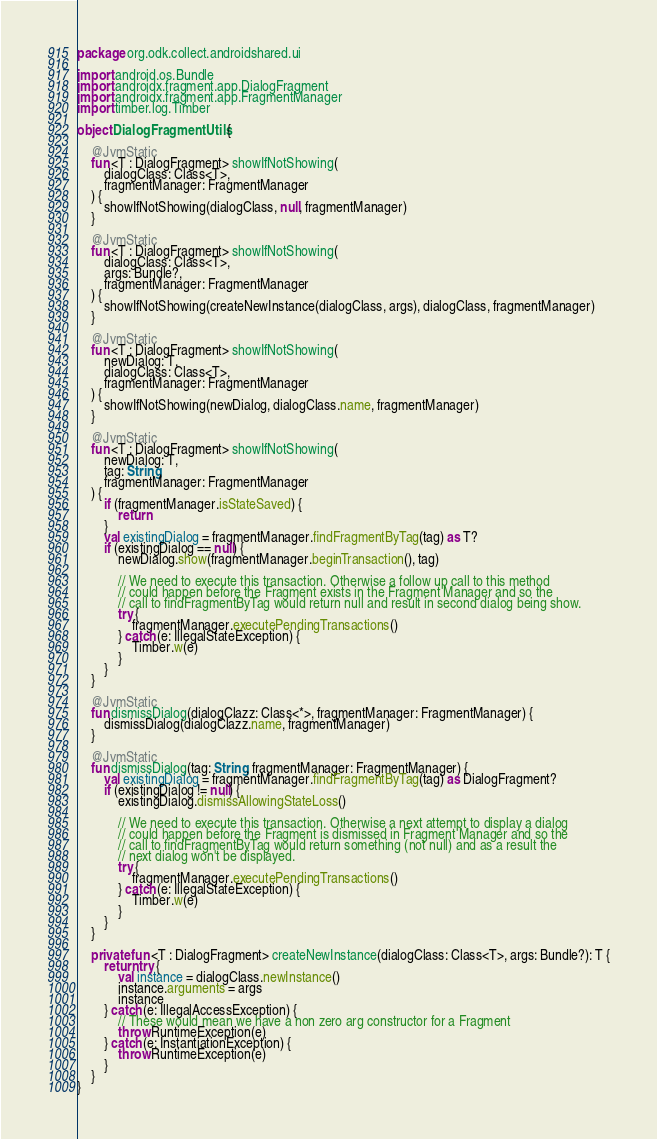Convert code to text. <code><loc_0><loc_0><loc_500><loc_500><_Kotlin_>package org.odk.collect.androidshared.ui

import android.os.Bundle
import androidx.fragment.app.DialogFragment
import androidx.fragment.app.FragmentManager
import timber.log.Timber

object DialogFragmentUtils {

    @JvmStatic
    fun <T : DialogFragment> showIfNotShowing(
        dialogClass: Class<T>,
        fragmentManager: FragmentManager
    ) {
        showIfNotShowing(dialogClass, null, fragmentManager)
    }

    @JvmStatic
    fun <T : DialogFragment> showIfNotShowing(
        dialogClass: Class<T>,
        args: Bundle?,
        fragmentManager: FragmentManager
    ) {
        showIfNotShowing(createNewInstance(dialogClass, args), dialogClass, fragmentManager)
    }

    @JvmStatic
    fun <T : DialogFragment> showIfNotShowing(
        newDialog: T,
        dialogClass: Class<T>,
        fragmentManager: FragmentManager
    ) {
        showIfNotShowing(newDialog, dialogClass.name, fragmentManager)
    }

    @JvmStatic
    fun <T : DialogFragment> showIfNotShowing(
        newDialog: T,
        tag: String,
        fragmentManager: FragmentManager
    ) {
        if (fragmentManager.isStateSaved) {
            return
        }
        val existingDialog = fragmentManager.findFragmentByTag(tag) as T?
        if (existingDialog == null) {
            newDialog.show(fragmentManager.beginTransaction(), tag)

            // We need to execute this transaction. Otherwise a follow up call to this method
            // could happen before the Fragment exists in the Fragment Manager and so the
            // call to findFragmentByTag would return null and result in second dialog being show.
            try {
                fragmentManager.executePendingTransactions()
            } catch (e: IllegalStateException) {
                Timber.w(e)
            }
        }
    }

    @JvmStatic
    fun dismissDialog(dialogClazz: Class<*>, fragmentManager: FragmentManager) {
        dismissDialog(dialogClazz.name, fragmentManager)
    }

    @JvmStatic
    fun dismissDialog(tag: String, fragmentManager: FragmentManager) {
        val existingDialog = fragmentManager.findFragmentByTag(tag) as DialogFragment?
        if (existingDialog != null) {
            existingDialog.dismissAllowingStateLoss()

            // We need to execute this transaction. Otherwise a next attempt to display a dialog
            // could happen before the Fragment is dismissed in Fragment Manager and so the
            // call to findFragmentByTag would return something (not null) and as a result the
            // next dialog won't be displayed.
            try {
                fragmentManager.executePendingTransactions()
            } catch (e: IllegalStateException) {
                Timber.w(e)
            }
        }
    }

    private fun <T : DialogFragment> createNewInstance(dialogClass: Class<T>, args: Bundle?): T {
        return try {
            val instance = dialogClass.newInstance()
            instance.arguments = args
            instance
        } catch (e: IllegalAccessException) {
            // These would mean we have a non zero arg constructor for a Fragment
            throw RuntimeException(e)
        } catch (e: InstantiationException) {
            throw RuntimeException(e)
        }
    }
}
</code> 